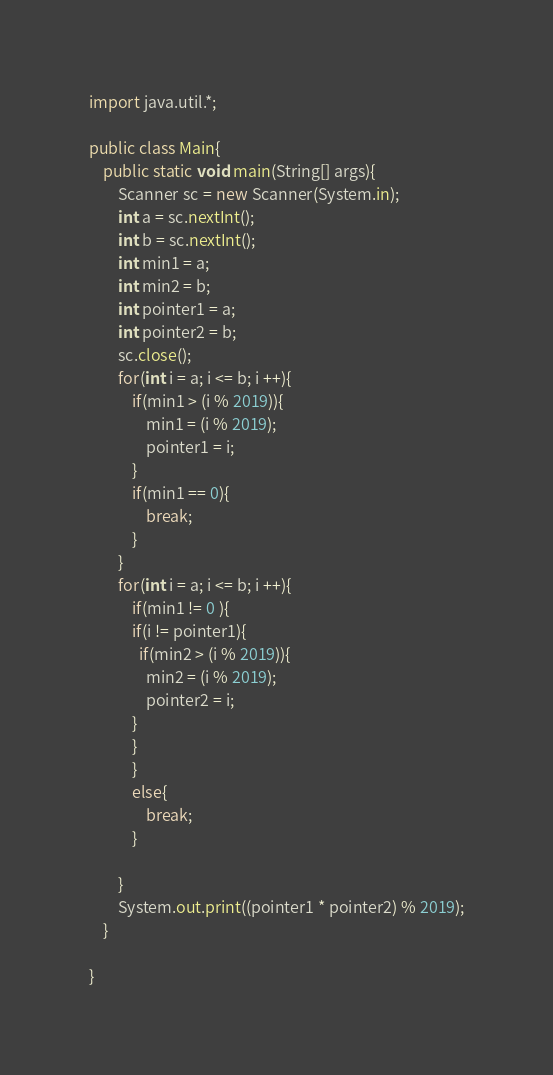<code> <loc_0><loc_0><loc_500><loc_500><_Java_>import java.util.*;
 
public class Main{
	public static void main(String[] args){
    	Scanner sc = new Scanner(System.in);
      	int a = sc.nextInt();
      	int b = sc.nextInt();
      	int min1 = a;
      	int min2 = b;
      	int pointer1 = a;
      	int pointer2 = b;
      	sc.close();
      	for(int i = a; i <= b; i ++){
          	if(min1 > (i % 2019)){
            	min1 = (i % 2019);
              	pointer1 = i;
            }
          	if(min1 == 0){
            	break;
            }
        }
      	for(int i = a; i <= b; i ++){
          	if(min1 != 0 ){
          	if(i != pointer1){
              if(min2 > (i % 2019)){
            	min2 = (i % 2019);
              	pointer2 = i;
            }
            }
            }
          	else{
            	break;
            }
          	
        }
      	System.out.print((pointer1 * pointer2) % 2019);
    }
 
}</code> 